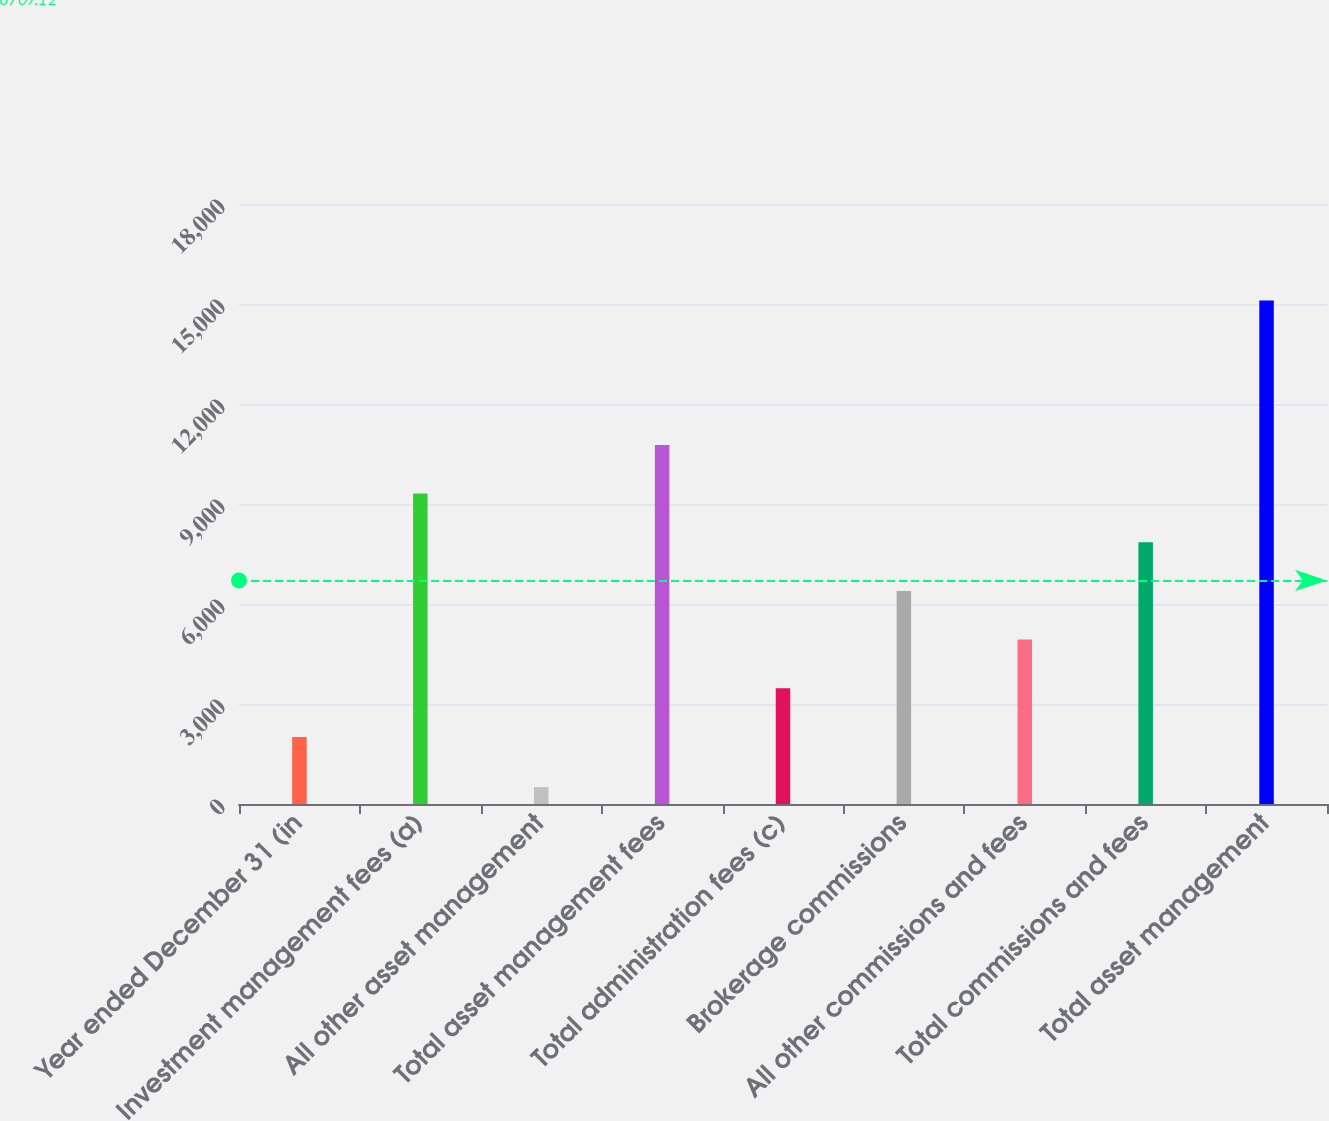Convert chart. <chart><loc_0><loc_0><loc_500><loc_500><bar_chart><fcel>Year ended December 31 (in<fcel>Investment management fees (a)<fcel>All other asset management<fcel>Total asset management fees<fcel>Total administration fees (c)<fcel>Brokerage commissions<fcel>All other commissions and fees<fcel>Total commissions and fees<fcel>Total asset management<nl><fcel>2013<fcel>9313.5<fcel>505<fcel>10773.6<fcel>3473.1<fcel>6393.3<fcel>4933.2<fcel>7853.4<fcel>15106<nl></chart> 